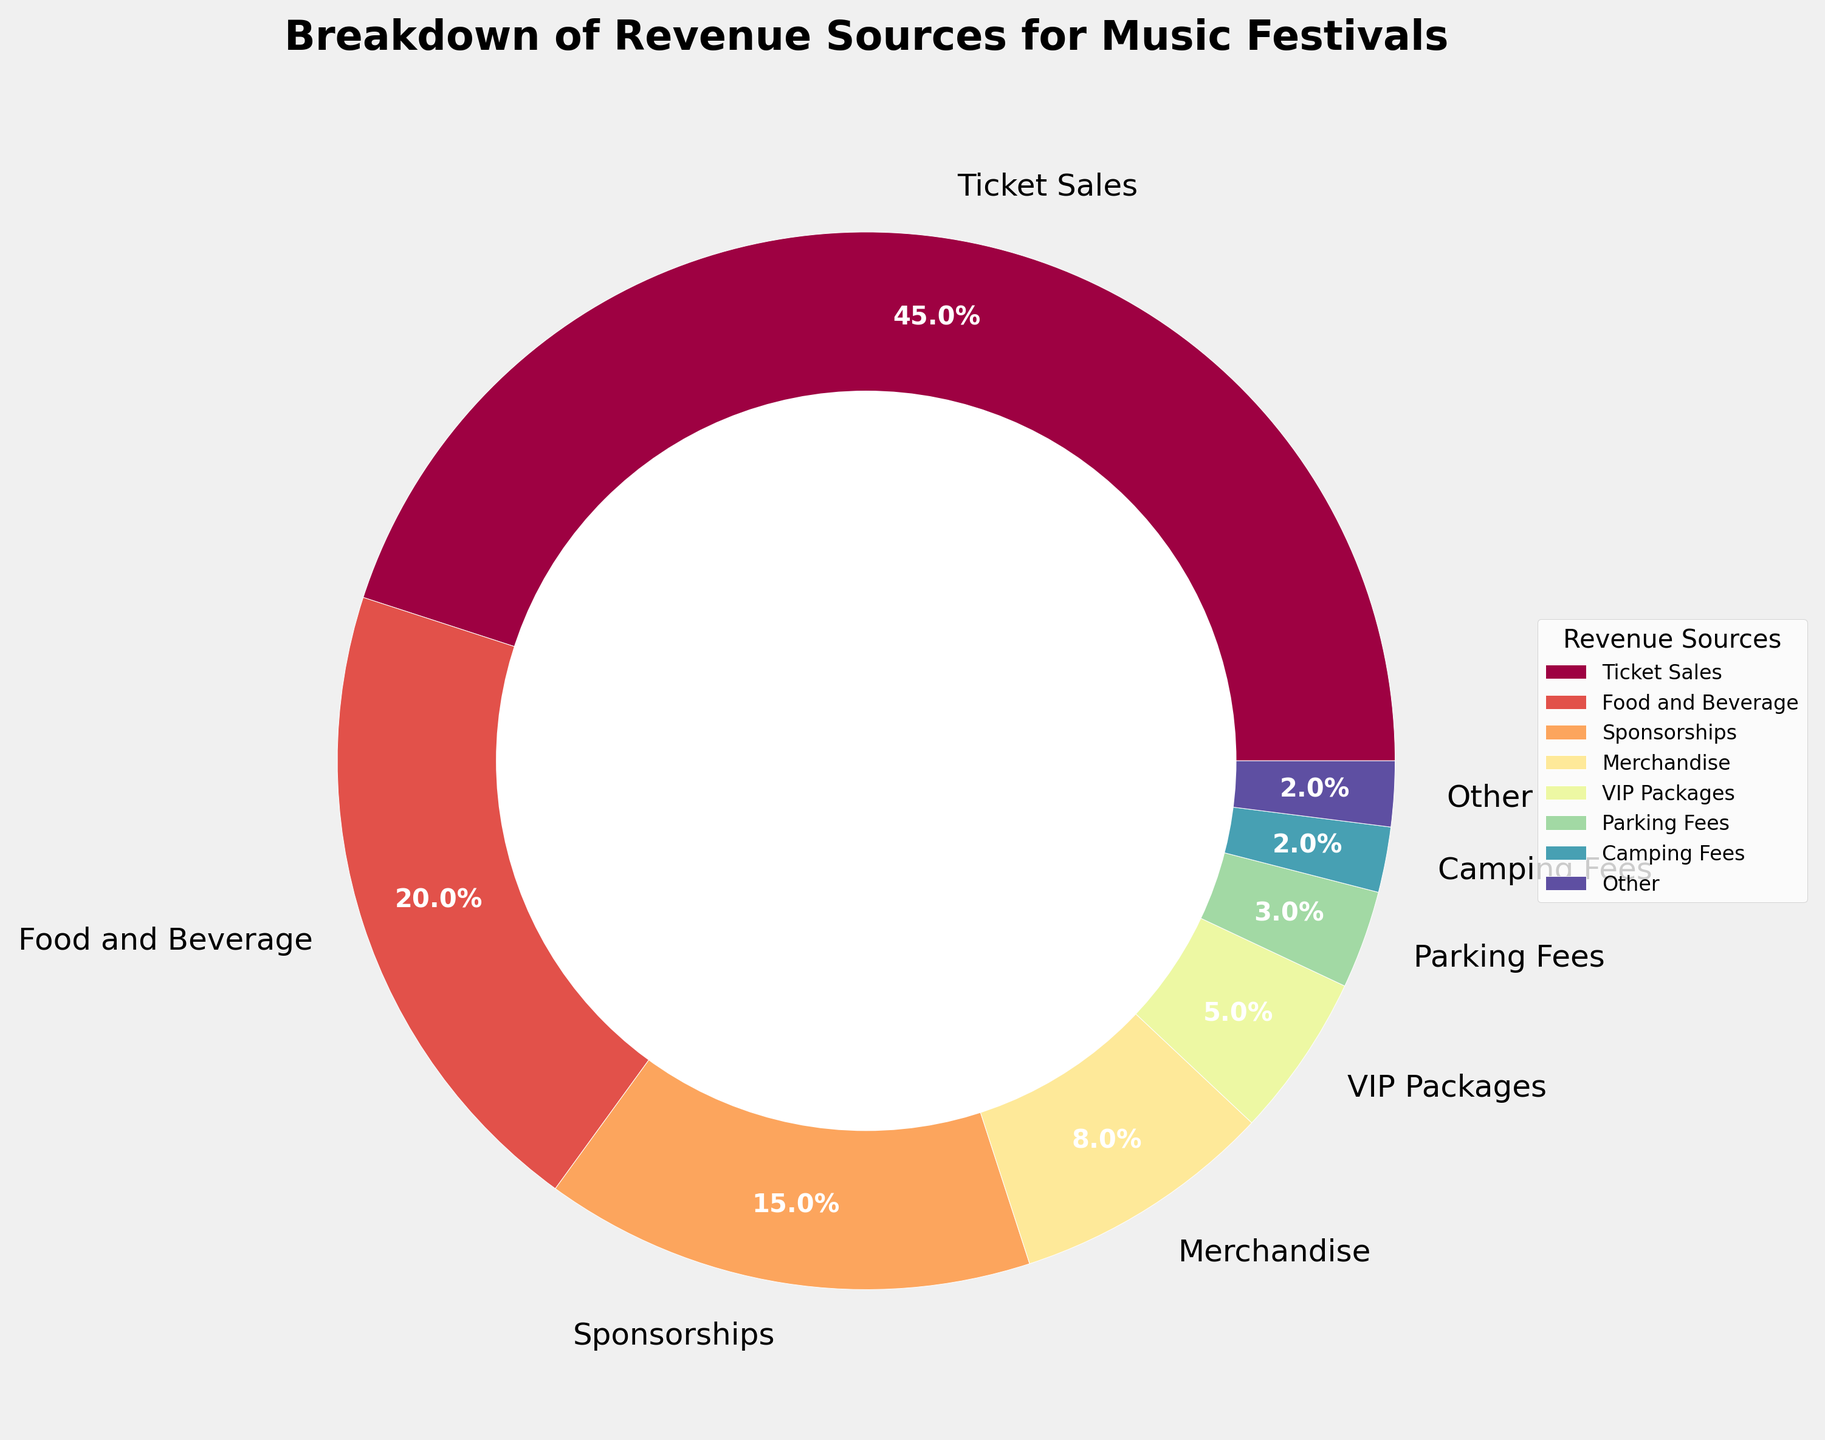What's the percentage of total revenue coming from Ticket Sales compared to Food and Beverage? Ticket Sales account for 45% and Food and Beverage account for 20%. To compare, Ticket Sales contribute more.
Answer: Ticket Sales contribute more by 25% What is the combined revenue percentage from Merchandise and VIP Packages? Merchandise accounts for 8% and VIP Packages for 5%. Their combined revenue is 8% + 5% = 13%.
Answer: 13% How much more revenue is generated from Sponsorships than from Parking Fees? Sponsorships generate 15% of the revenue while Parking Fees generate 3%. The difference is 15% - 3% = 12%.
Answer: 12% Identify the revenue sources that are grouped under 'Other'. 'Other' categories are small slices with less than 2% each: Camping Fees (2%), Live Stream Revenue (1%), Mobile App Purchases (0.5%), On-Site Activations (0.3%), ATM Fees (0.1%), Vendor Booth Rentals (0.1%).
Answer: Camping Fees, Live Stream Revenue, Mobile App Purchases, On-Site Activations, ATM Fees, Vendor Booth Rentals What is the second largest revenue source after Ticket Sales? The second largest revenue source is Food and Beverage at 20%.
Answer: Food and Beverage List all revenue sources that individually contribute less than 5%. Revenue sources contributing less than 5% are Merchandise (8%), VIP Packages (5%), Parking Fees (3%), and those in the 'Other' category.
Answer: Parking Fees, Camping Fees, Live Stream Revenue, Mobile App Purchases, On-Site Activations, ATM Fees, Vendor Booth Rentals What visual feature distinguishes the largest revenue source on the chart? The largest revenue source, Ticket Sales, has the largest colored wedge slice in the pie chart.
Answer: Largest colored wedge slice What percentage of revenue comes from the sum of Sponsorships, Merchandise, and VIP Packages? Sponsorships: 15%, Merchandise: 8%, VIP Packages: 5%. The total is 15% + 8% + 5% = 28%.
Answer: 28% Compare the revenue generated by Live Stream Revenue with Mobile App Purchases. Which one contributes more? Live Stream Revenue contributes 1%, while Mobile App Purchases contribute 0.5%. Thus, Live Stream Revenue contributes more.
Answer: Live Stream Revenue Approximately what percentage of total revenue does 'Other' represent? Adding all small slices under 2%: 2% + 1% + 0.5% + 0.3% + 0.1% + 0.1% = 4%.
Answer: 4% 